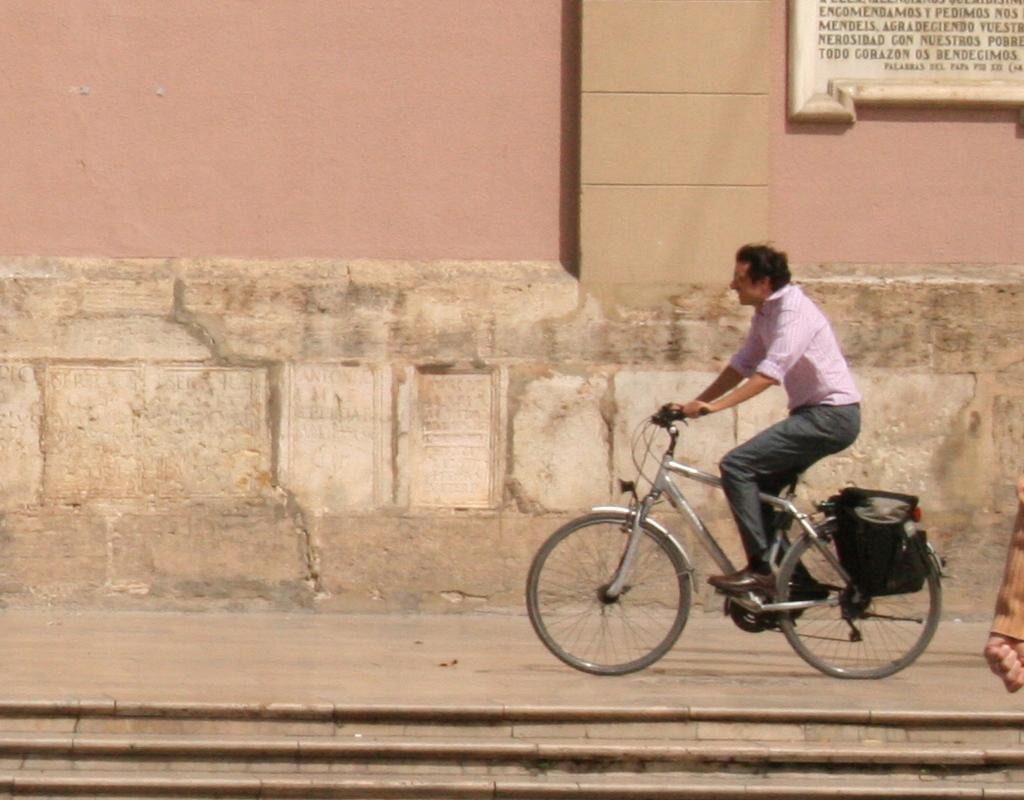Who is present in the image? There is a man in the image. What is the man wearing? The man is wearing a pink shirt. What activity is the man engaged in? The man is riding a bicycle. What can be seen in the background of the image? There is a wall in the background of the image. What type of shoes is the man drawing on the wall with chalk in the image? There is no mention of shoes or chalk in the image; the man is riding a bicycle and wearing a pink shirt. 